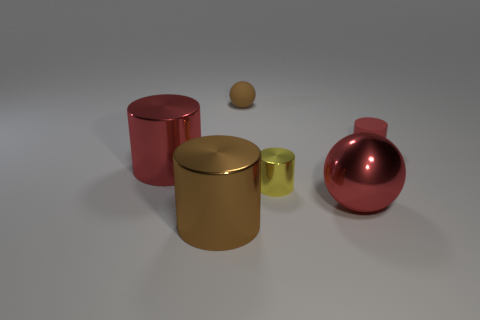What is the color of the other big thing that is the same shape as the brown rubber object? The color of the large object that shares the shape with the brown rubber object, which appears to be a cylindrical container with a lid, is a metallic red. This other object has a reflective surface similar to the brown one, except for its distinct red hue. 